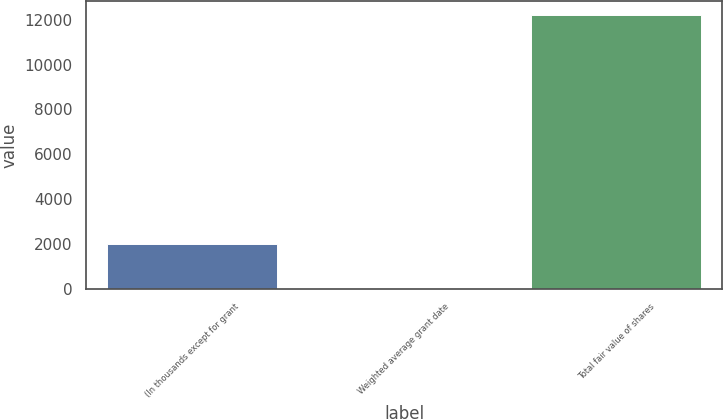Convert chart. <chart><loc_0><loc_0><loc_500><loc_500><bar_chart><fcel>(In thousands except for grant<fcel>Weighted average grant date<fcel>Total fair value of shares<nl><fcel>2016<fcel>57.22<fcel>12221<nl></chart> 